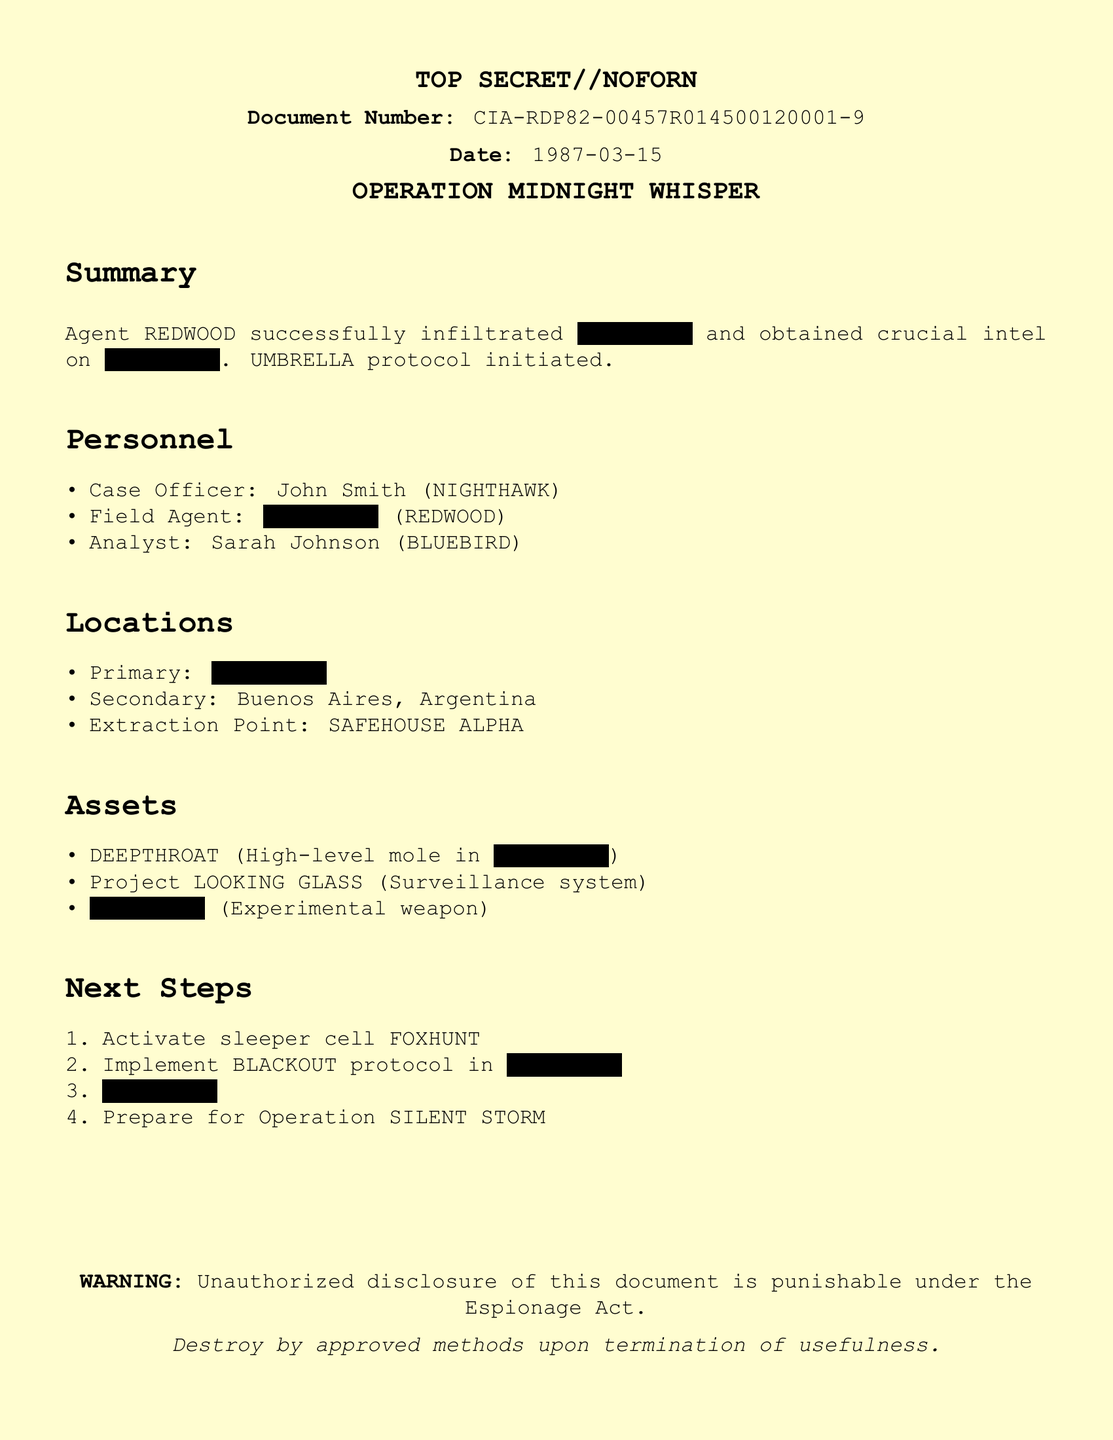what is the document number? The document number is clearly stated at the top part of the document for reference.
Answer: CIA-RDP82-00457R014500120001-9 who is the Case Officer? The Case Officer name is listed under the personnel section with their alias.
Answer: John Smith (NIGHTHAWK) what is the date of the document? The date appears near the document number, indicating when it was created.
Answer: 1987-03-15 what is the primary location mentioned? The primary location is mentioned in the locations section but is redacted.
Answer: XXXXXXXX what is the name of the operation? The operation title is prominently displayed in the title section of the document.
Answer: OPERATION MIDNIGHT WHISPER who is the Field Agent? The Field Agent's alias is included in the personnel section, although their name is redacted.
Answer: XXXXXXXX (REDWOOD) what protocol was initiated? This information is mentioned in the summary section.
Answer: UMBRELLA protocol what is the extraction point? The extraction point is specified in the locations section of the document.
Answer: SAFEHOUSE ALPHA how many next steps are listed? The number of next steps can be counted from the enumerated section detailing the actions to take.
Answer: 4 